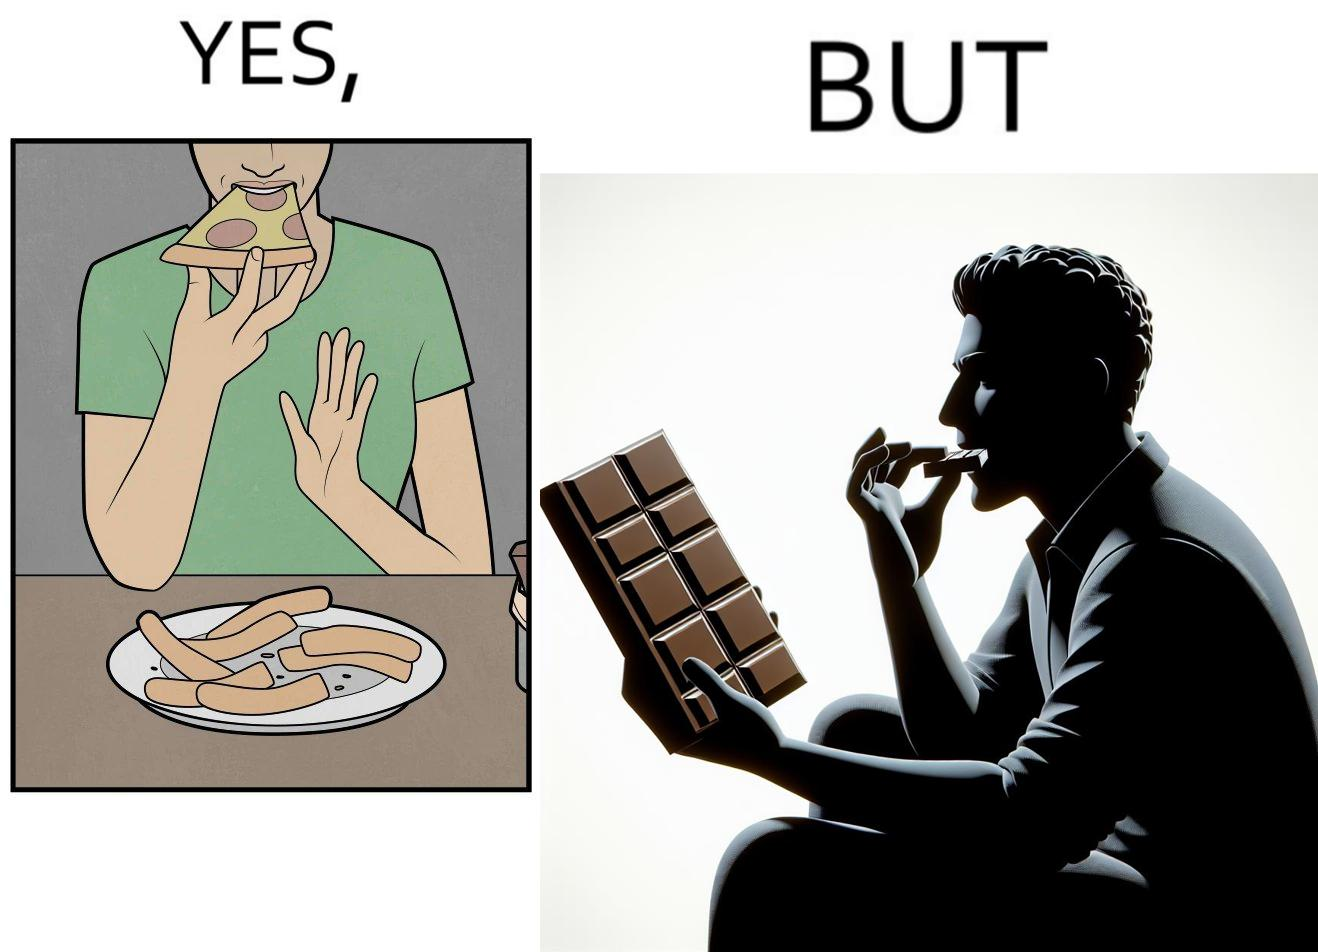What is shown in this image? the irony in this image is that people waste pizza crust by saying that it is too hard, while they eat hard chocolate without any complaints 